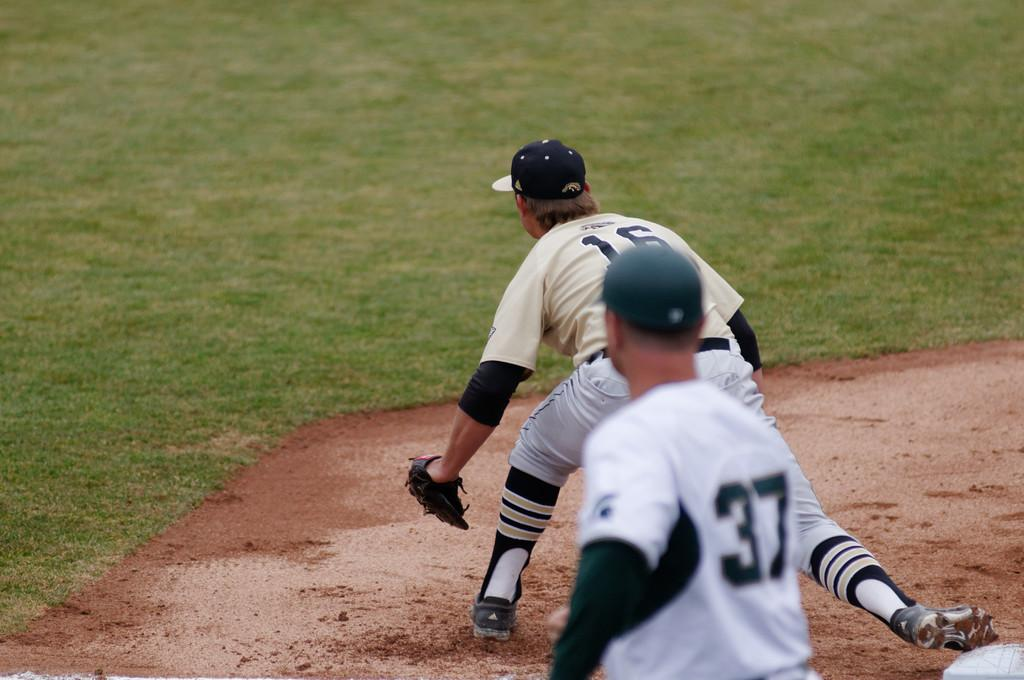<image>
Give a short and clear explanation of the subsequent image. Baseball player number 16 is about to catch the ball while player 37 watches. 